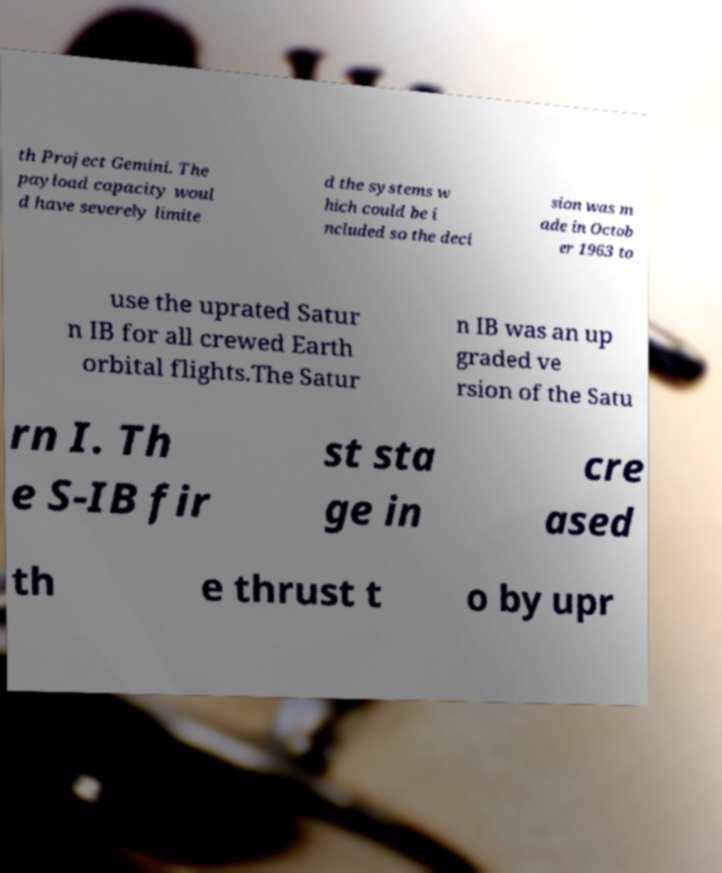Please identify and transcribe the text found in this image. th Project Gemini. The payload capacity woul d have severely limite d the systems w hich could be i ncluded so the deci sion was m ade in Octob er 1963 to use the uprated Satur n IB for all crewed Earth orbital flights.The Satur n IB was an up graded ve rsion of the Satu rn I. Th e S-IB fir st sta ge in cre ased th e thrust t o by upr 